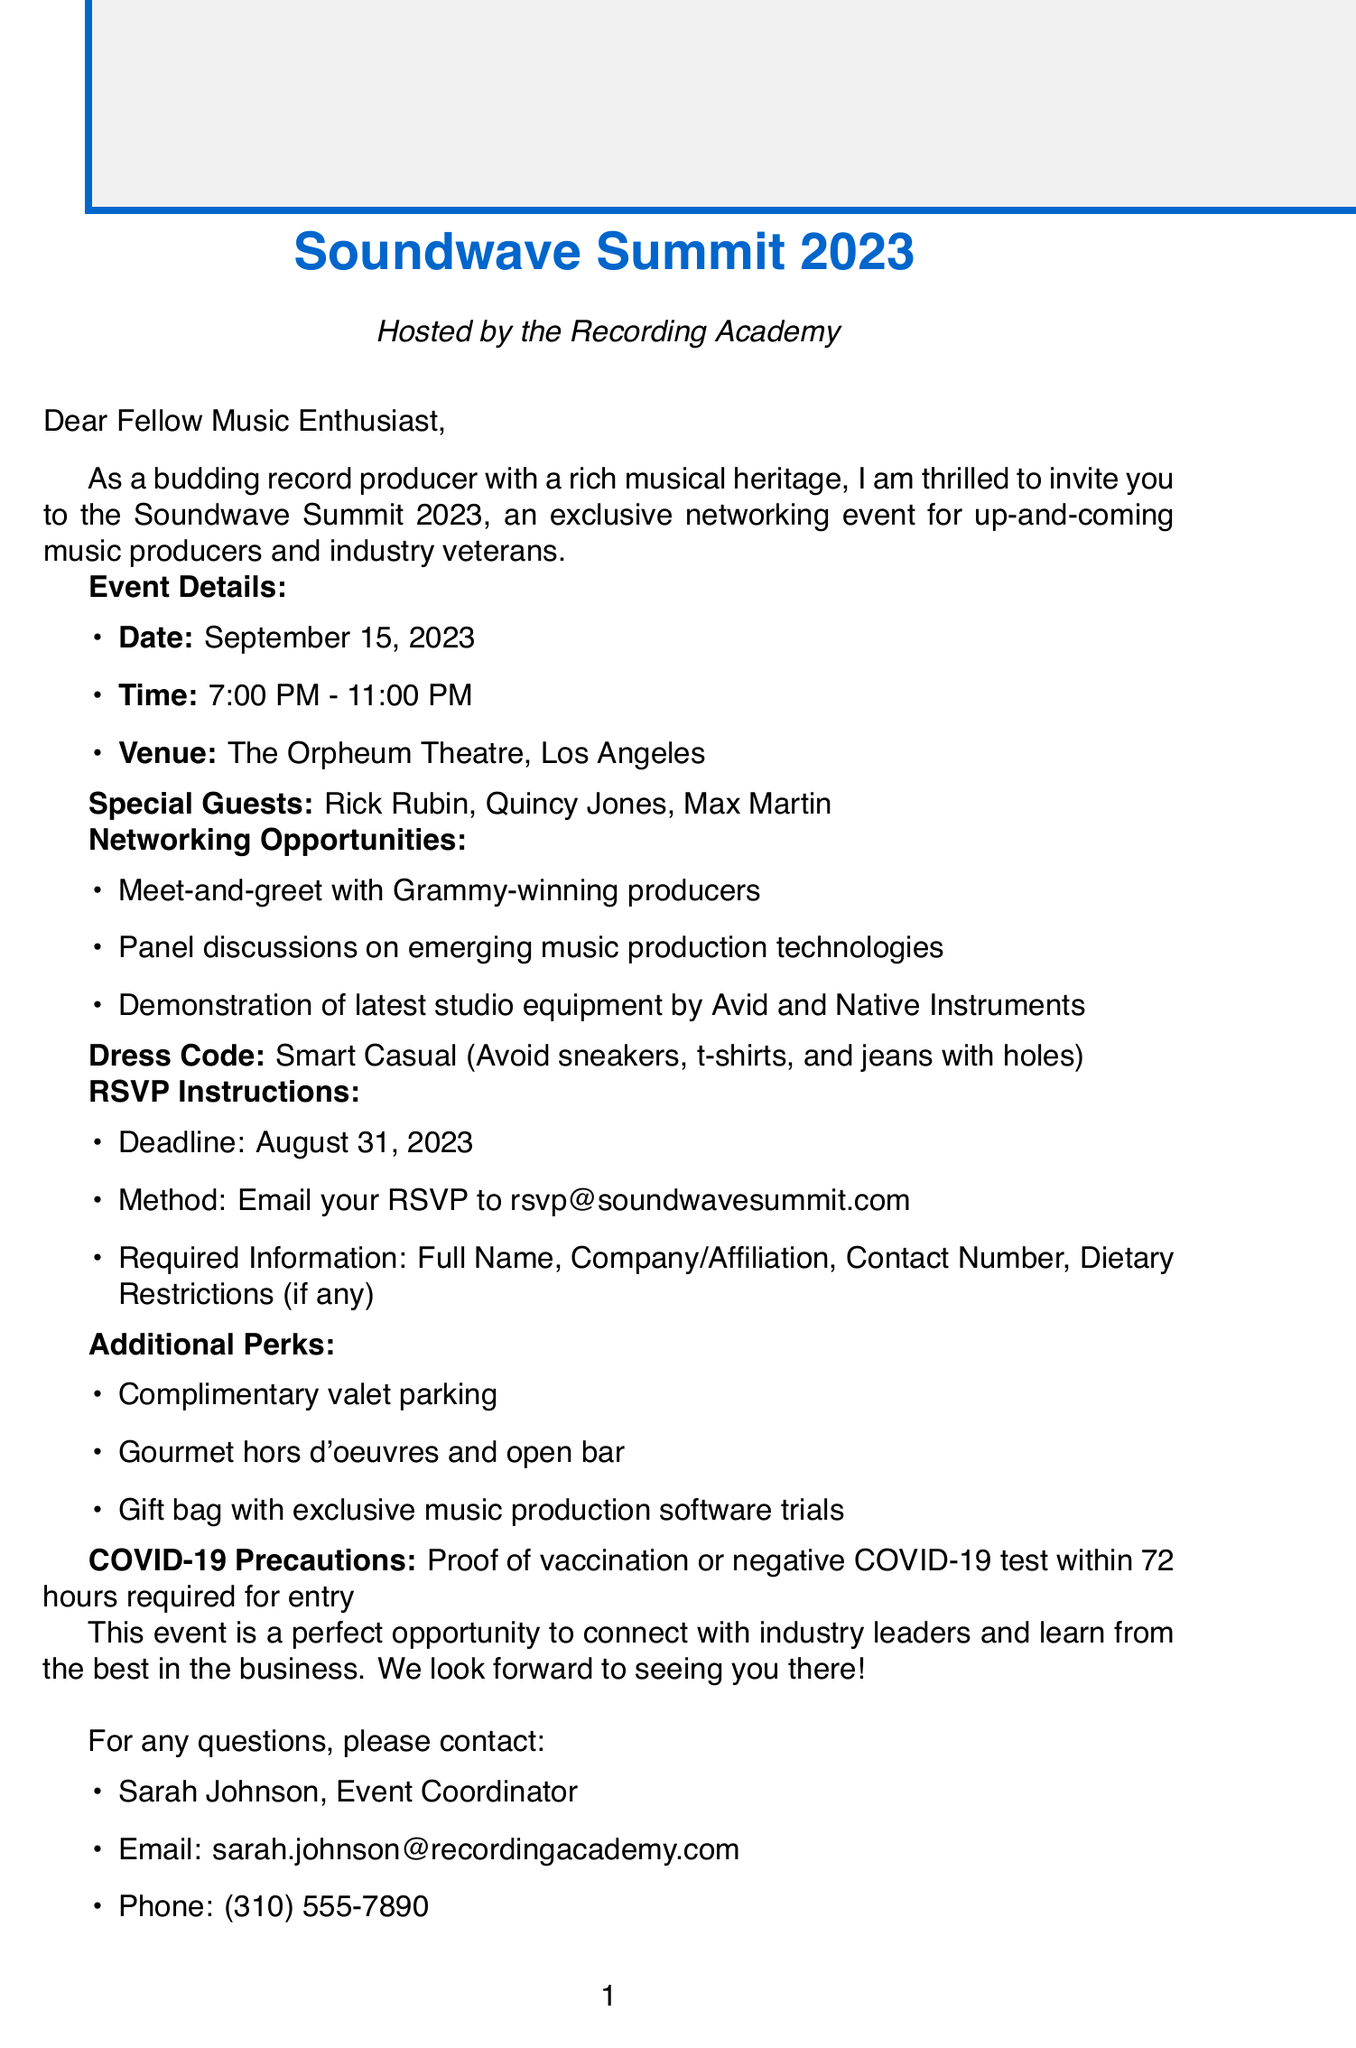What is the event name? The event name is explicitly stated at the beginning of the document as "Soundwave Summit 2023."
Answer: Soundwave Summit 2023 Who is hosting the event? The host of the event is mentioned directly in the introduction of the document.
Answer: Recording Academy When does the event take place? The document provides the date of the event in the "Event Details" section, which specifically states the date.
Answer: September 15, 2023 What is the dress code for the event? The dress code is clearly outlined in the document, indicating the style attendees should adhere to.
Answer: Smart Casual What special guests are mentioned? The document lists notable individuals invited to the event in a specific section.
Answer: Rick Rubin, Quincy Jones, Max Martin What is the RSVP deadline? The document explicitly states the deadline for RSVPs in the RSVP Instructions section.
Answer: August 31, 2023 What type of networking opportunities are available? The document describes the networking opportunities attendees can expect, indicating the activities provided.
Answer: Meet-and-greet, Panel discussions, Demonstration What are the COVID-19 precautions? The document specifically details the health and safety measures required for entry to the event.
Answer: Proof of vaccination or negative COVID-19 test Who should attendees contact for questions? The document provides a contact person and their details for attendees who have inquiries.
Answer: Sarah Johnson, sarah.johnson@recordingacademy.com 